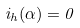<formula> <loc_0><loc_0><loc_500><loc_500>i _ { h } ( \alpha ) = 0</formula> 